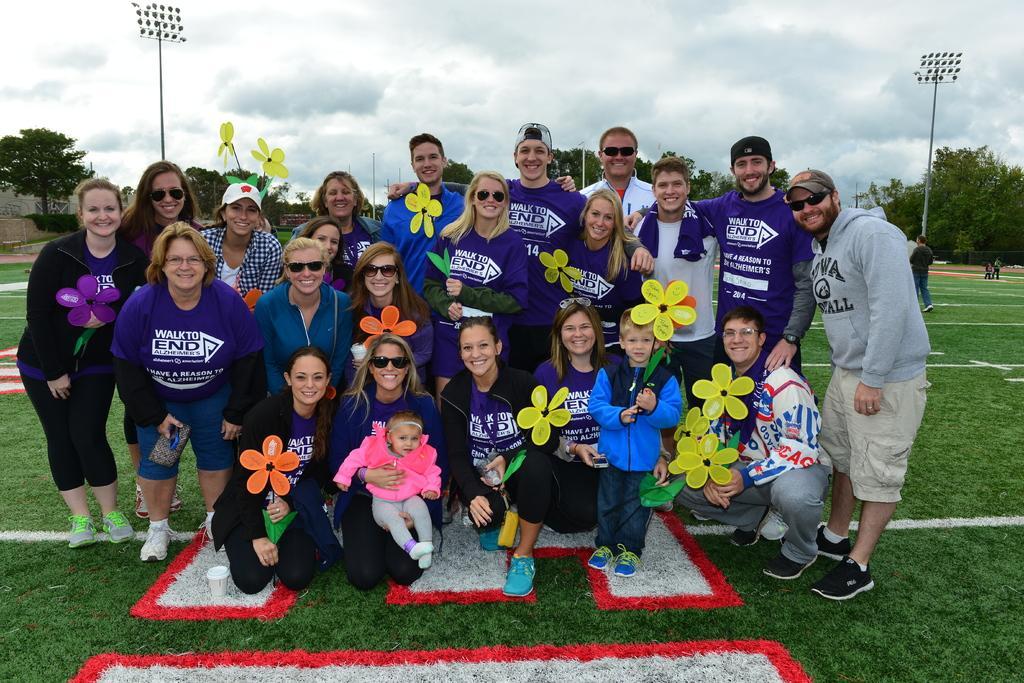How would you summarize this image in a sentence or two? This image is taken outdoors. At the bottom of the image there is a ground with grass on it. In the middle of the image there are many people standing on the ground and a few are in a squatting position and a few are holding artificial flowers in their hands. In the background there are a few trees and poles with lights. At the top of the image there is a sky with clouds. 